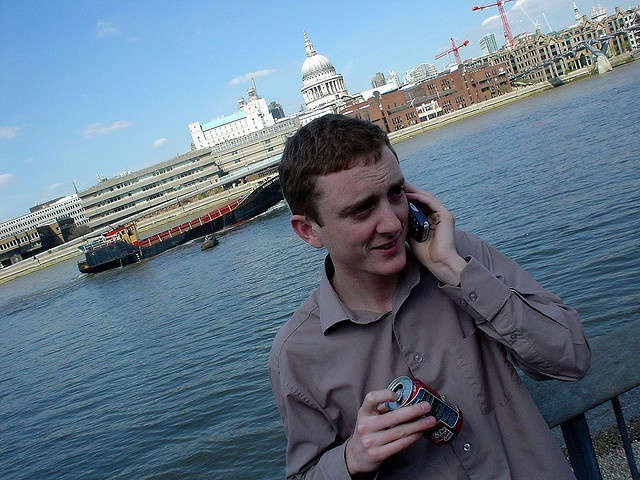Describe the objects in this image and their specific colors. I can see people in gray and black tones, boat in gray, black, and darkgray tones, and cell phone in gray, black, and navy tones in this image. 